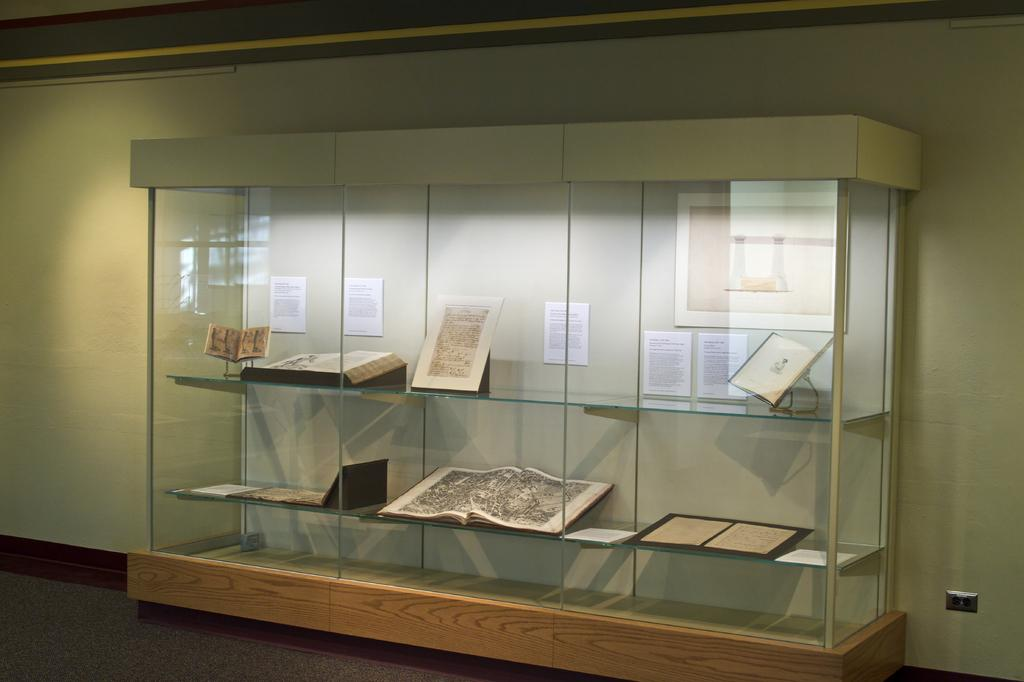What type of structure is present in the image? There is a glass cabin in the image. What feature does the glass cabin have? The glass cabin has shelves. What items can be found on the shelves? There are books on the shelves. What can be seen on the wall inside the glass cabin? There are posters and a frame on the wall. Where is the brother playing with the ball in the image? There is no brother or ball present in the image; it features a glass cabin with shelves, books, posters, and a frame on the wall. What type of clam is visible on the shelves in the image? There are no clams present on the shelves in the image; it contains books instead. 